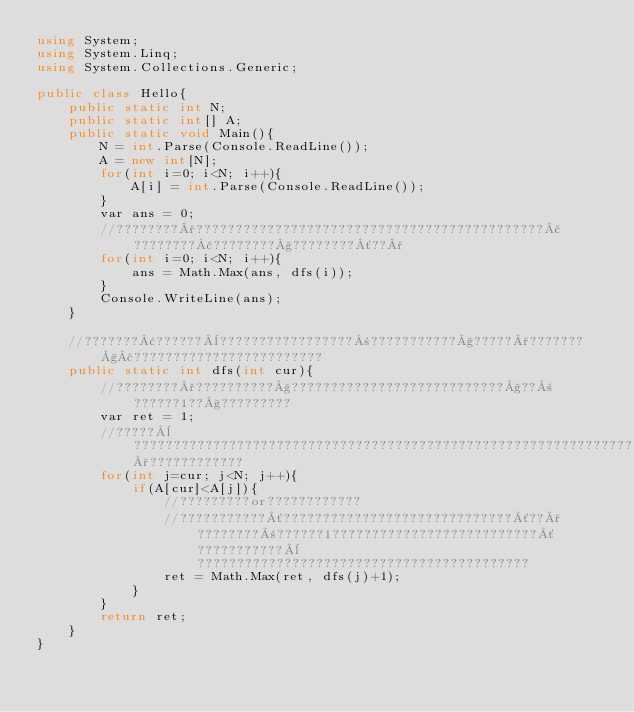<code> <loc_0><loc_0><loc_500><loc_500><_C#_>using System;
using System.Linq;
using System.Collections.Generic;

public class Hello{
    public static int N;
    public static int[] A;
    public static void Main(){
        N = int.Parse(Console.ReadLine());
        A = new int[N];
        for(int i=0; i<N; i++){
            A[i] = int.Parse(Console.ReadLine());
        }
        var ans = 0;
        //????????°????????????????????????????????????????????£????????£????????§????????´??°
        for(int i=0; i<N; i++){
            ans = Math.Max(ans, dfs(i));
        }
        Console.WriteLine(ans);
    }
    
    //???????¢??????¨?????????????????±???????????§?????°???????§£????????????????????????
    public static int dfs(int cur){
        //????????°??????????§???????????????????????????§??±??????1??§?????????
        var ret = 1;
        //?????¨?????????????????????????????????????????????????????????????????°????????????
        for(int j=cur; j<N; j++){
            if(A[cur]<A[j]){
                //?????????or????????????
                //???????????´?????????????????????????????´??°????????±??????1??????????????????????????´???????????¨??????????????????????????????????????????
                ret = Math.Max(ret, dfs(j)+1);
            }
        }
        return ret;
    }
}</code> 